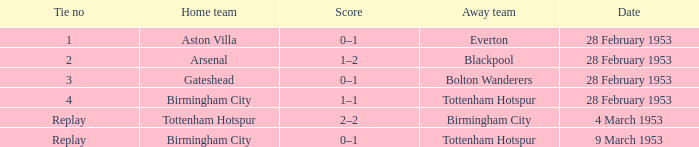Which Score has a Date of 28 february 1953, and a Tie no of 3? 0–1. 